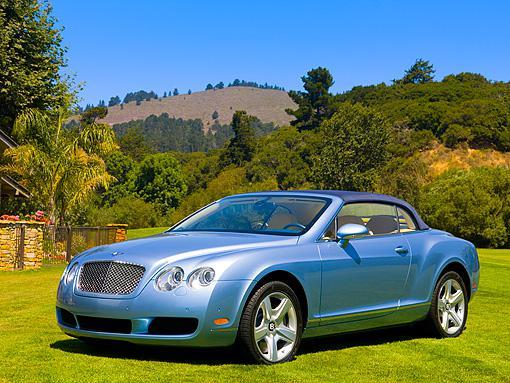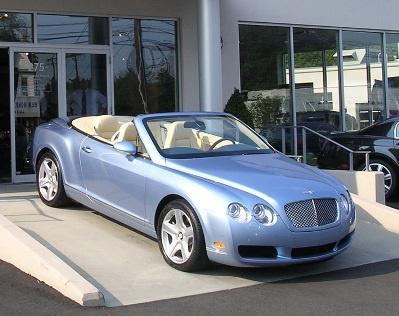The first image is the image on the left, the second image is the image on the right. For the images displayed, is the sentence "The left image shows a convertible car with the top up while the right image shows a convertible with the top down" factually correct? Answer yes or no. Yes. The first image is the image on the left, the second image is the image on the right. Considering the images on both sides, is "The top is up on the image on the left." valid? Answer yes or no. Yes. 